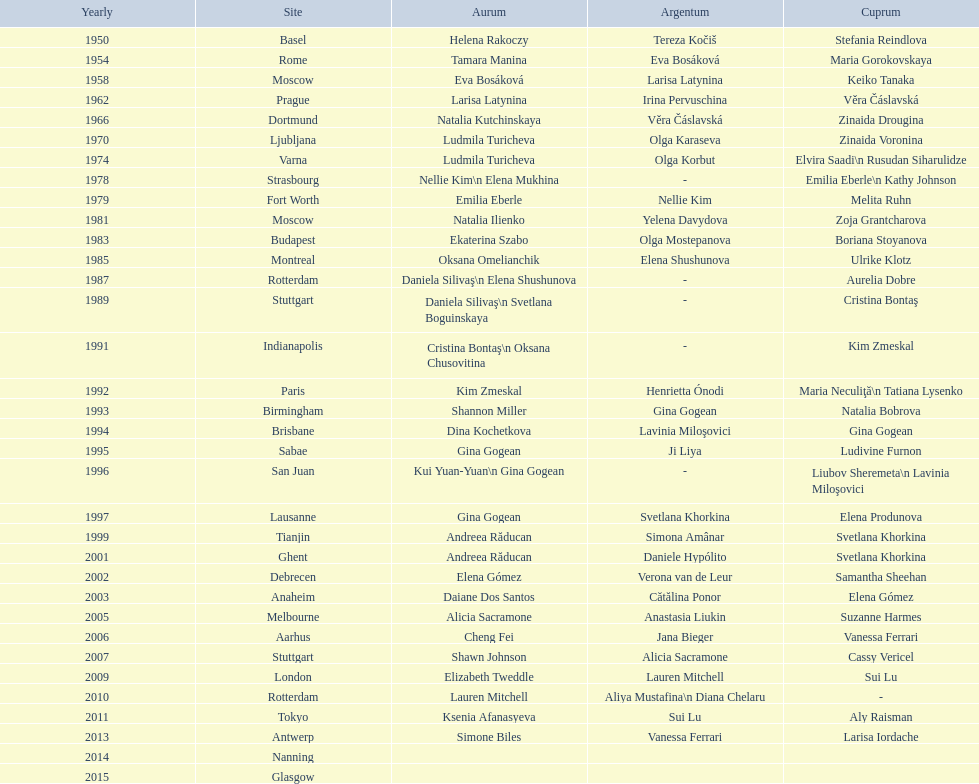What is the total number of russian gymnasts that have won silver. 8. 